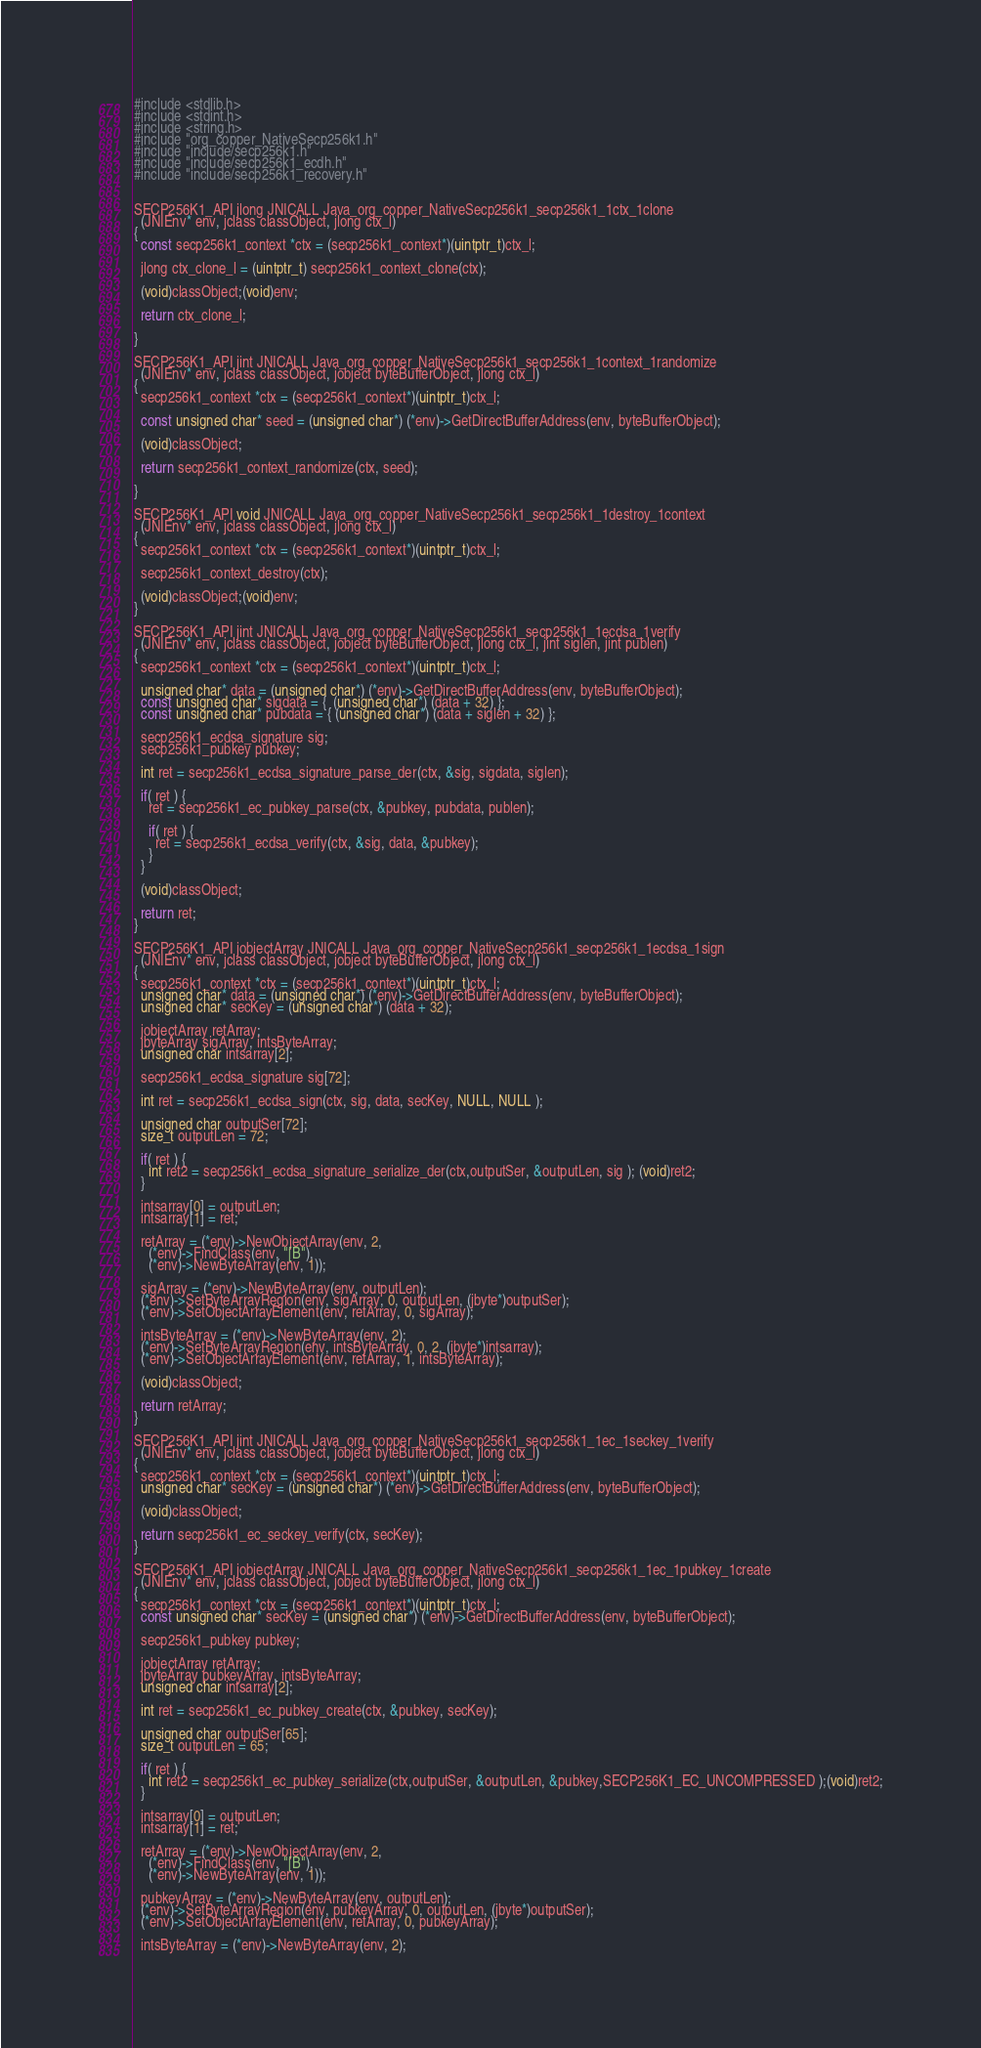Convert code to text. <code><loc_0><loc_0><loc_500><loc_500><_C_>#include <stdlib.h>
#include <stdint.h>
#include <string.h>
#include "org_copper_NativeSecp256k1.h"
#include "include/secp256k1.h"
#include "include/secp256k1_ecdh.h"
#include "include/secp256k1_recovery.h"


SECP256K1_API jlong JNICALL Java_org_copper_NativeSecp256k1_secp256k1_1ctx_1clone
  (JNIEnv* env, jclass classObject, jlong ctx_l)
{
  const secp256k1_context *ctx = (secp256k1_context*)(uintptr_t)ctx_l;

  jlong ctx_clone_l = (uintptr_t) secp256k1_context_clone(ctx);

  (void)classObject;(void)env;

  return ctx_clone_l;

}

SECP256K1_API jint JNICALL Java_org_copper_NativeSecp256k1_secp256k1_1context_1randomize
  (JNIEnv* env, jclass classObject, jobject byteBufferObject, jlong ctx_l)
{
  secp256k1_context *ctx = (secp256k1_context*)(uintptr_t)ctx_l;

  const unsigned char* seed = (unsigned char*) (*env)->GetDirectBufferAddress(env, byteBufferObject);

  (void)classObject;

  return secp256k1_context_randomize(ctx, seed);

}

SECP256K1_API void JNICALL Java_org_copper_NativeSecp256k1_secp256k1_1destroy_1context
  (JNIEnv* env, jclass classObject, jlong ctx_l)
{
  secp256k1_context *ctx = (secp256k1_context*)(uintptr_t)ctx_l;

  secp256k1_context_destroy(ctx);

  (void)classObject;(void)env;
}

SECP256K1_API jint JNICALL Java_org_copper_NativeSecp256k1_secp256k1_1ecdsa_1verify
  (JNIEnv* env, jclass classObject, jobject byteBufferObject, jlong ctx_l, jint siglen, jint publen)
{
  secp256k1_context *ctx = (secp256k1_context*)(uintptr_t)ctx_l;

  unsigned char* data = (unsigned char*) (*env)->GetDirectBufferAddress(env, byteBufferObject);
  const unsigned char* sigdata = {  (unsigned char*) (data + 32) };
  const unsigned char* pubdata = { (unsigned char*) (data + siglen + 32) };

  secp256k1_ecdsa_signature sig;
  secp256k1_pubkey pubkey;

  int ret = secp256k1_ecdsa_signature_parse_der(ctx, &sig, sigdata, siglen);

  if( ret ) {
    ret = secp256k1_ec_pubkey_parse(ctx, &pubkey, pubdata, publen);

    if( ret ) {
      ret = secp256k1_ecdsa_verify(ctx, &sig, data, &pubkey);
    }
  }

  (void)classObject;

  return ret;
}

SECP256K1_API jobjectArray JNICALL Java_org_copper_NativeSecp256k1_secp256k1_1ecdsa_1sign
  (JNIEnv* env, jclass classObject, jobject byteBufferObject, jlong ctx_l)
{
  secp256k1_context *ctx = (secp256k1_context*)(uintptr_t)ctx_l;
  unsigned char* data = (unsigned char*) (*env)->GetDirectBufferAddress(env, byteBufferObject);
  unsigned char* secKey = (unsigned char*) (data + 32);

  jobjectArray retArray;
  jbyteArray sigArray, intsByteArray;
  unsigned char intsarray[2];

  secp256k1_ecdsa_signature sig[72];

  int ret = secp256k1_ecdsa_sign(ctx, sig, data, secKey, NULL, NULL );

  unsigned char outputSer[72];
  size_t outputLen = 72;

  if( ret ) {
    int ret2 = secp256k1_ecdsa_signature_serialize_der(ctx,outputSer, &outputLen, sig ); (void)ret2;
  }

  intsarray[0] = outputLen;
  intsarray[1] = ret;

  retArray = (*env)->NewObjectArray(env, 2,
    (*env)->FindClass(env, "[B"),
    (*env)->NewByteArray(env, 1));

  sigArray = (*env)->NewByteArray(env, outputLen);
  (*env)->SetByteArrayRegion(env, sigArray, 0, outputLen, (jbyte*)outputSer);
  (*env)->SetObjectArrayElement(env, retArray, 0, sigArray);

  intsByteArray = (*env)->NewByteArray(env, 2);
  (*env)->SetByteArrayRegion(env, intsByteArray, 0, 2, (jbyte*)intsarray);
  (*env)->SetObjectArrayElement(env, retArray, 1, intsByteArray);

  (void)classObject;

  return retArray;
}

SECP256K1_API jint JNICALL Java_org_copper_NativeSecp256k1_secp256k1_1ec_1seckey_1verify
  (JNIEnv* env, jclass classObject, jobject byteBufferObject, jlong ctx_l)
{
  secp256k1_context *ctx = (secp256k1_context*)(uintptr_t)ctx_l;
  unsigned char* secKey = (unsigned char*) (*env)->GetDirectBufferAddress(env, byteBufferObject);

  (void)classObject;

  return secp256k1_ec_seckey_verify(ctx, secKey);
}

SECP256K1_API jobjectArray JNICALL Java_org_copper_NativeSecp256k1_secp256k1_1ec_1pubkey_1create
  (JNIEnv* env, jclass classObject, jobject byteBufferObject, jlong ctx_l)
{
  secp256k1_context *ctx = (secp256k1_context*)(uintptr_t)ctx_l;
  const unsigned char* secKey = (unsigned char*) (*env)->GetDirectBufferAddress(env, byteBufferObject);

  secp256k1_pubkey pubkey;

  jobjectArray retArray;
  jbyteArray pubkeyArray, intsByteArray;
  unsigned char intsarray[2];

  int ret = secp256k1_ec_pubkey_create(ctx, &pubkey, secKey);

  unsigned char outputSer[65];
  size_t outputLen = 65;

  if( ret ) {
    int ret2 = secp256k1_ec_pubkey_serialize(ctx,outputSer, &outputLen, &pubkey,SECP256K1_EC_UNCOMPRESSED );(void)ret2;
  }

  intsarray[0] = outputLen;
  intsarray[1] = ret;

  retArray = (*env)->NewObjectArray(env, 2,
    (*env)->FindClass(env, "[B"),
    (*env)->NewByteArray(env, 1));

  pubkeyArray = (*env)->NewByteArray(env, outputLen);
  (*env)->SetByteArrayRegion(env, pubkeyArray, 0, outputLen, (jbyte*)outputSer);
  (*env)->SetObjectArrayElement(env, retArray, 0, pubkeyArray);

  intsByteArray = (*env)->NewByteArray(env, 2);</code> 